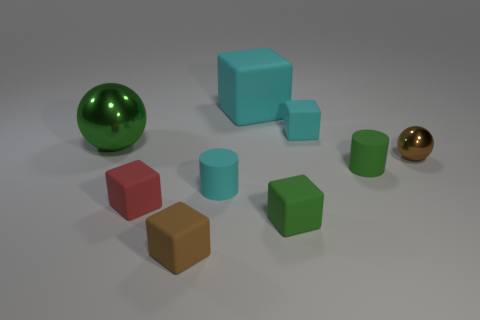How many cyan cubes must be subtracted to get 1 cyan cubes? 1 Subtract all large cubes. How many cubes are left? 4 Subtract all green cubes. Subtract all red cylinders. How many cubes are left? 4 Add 1 matte cubes. How many objects exist? 10 Subtract all cubes. How many objects are left? 4 Add 8 tiny brown blocks. How many tiny brown blocks are left? 9 Add 8 spheres. How many spheres exist? 10 Subtract 0 purple blocks. How many objects are left? 9 Subtract all big green metal blocks. Subtract all small rubber blocks. How many objects are left? 5 